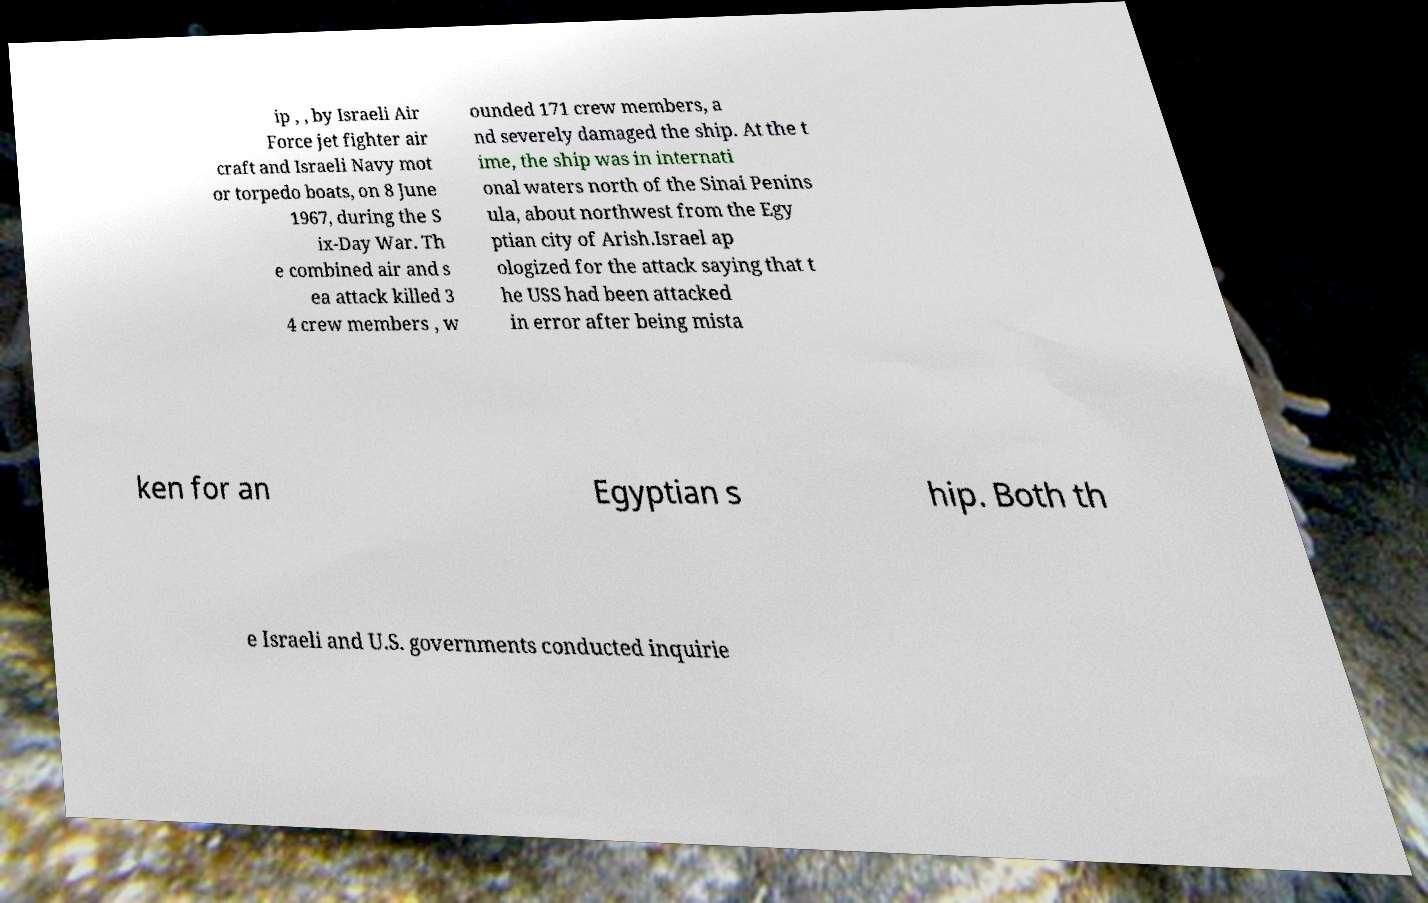Please read and relay the text visible in this image. What does it say? ip , , by Israeli Air Force jet fighter air craft and Israeli Navy mot or torpedo boats, on 8 June 1967, during the S ix-Day War. Th e combined air and s ea attack killed 3 4 crew members , w ounded 171 crew members, a nd severely damaged the ship. At the t ime, the ship was in internati onal waters north of the Sinai Penins ula, about northwest from the Egy ptian city of Arish.Israel ap ologized for the attack saying that t he USS had been attacked in error after being mista ken for an Egyptian s hip. Both th e Israeli and U.S. governments conducted inquirie 